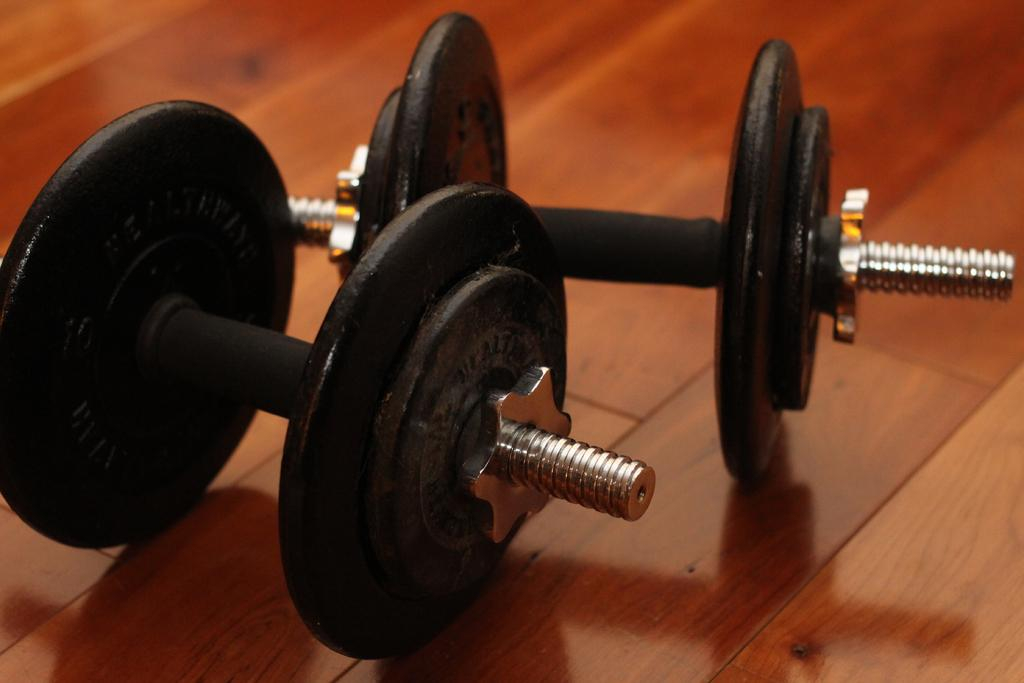What type of equipment is present in the image? There are two black dumbbells in the image. What is the color of the surface on which the dumbbells are placed? The dumbbells are on a brown surface. How many horses are visible in the image? There are no horses present in the image; it features two black dumbbells on a brown surface. What type of cushion is used to support the cake in the image? There is no cake or cushion present in the image. 